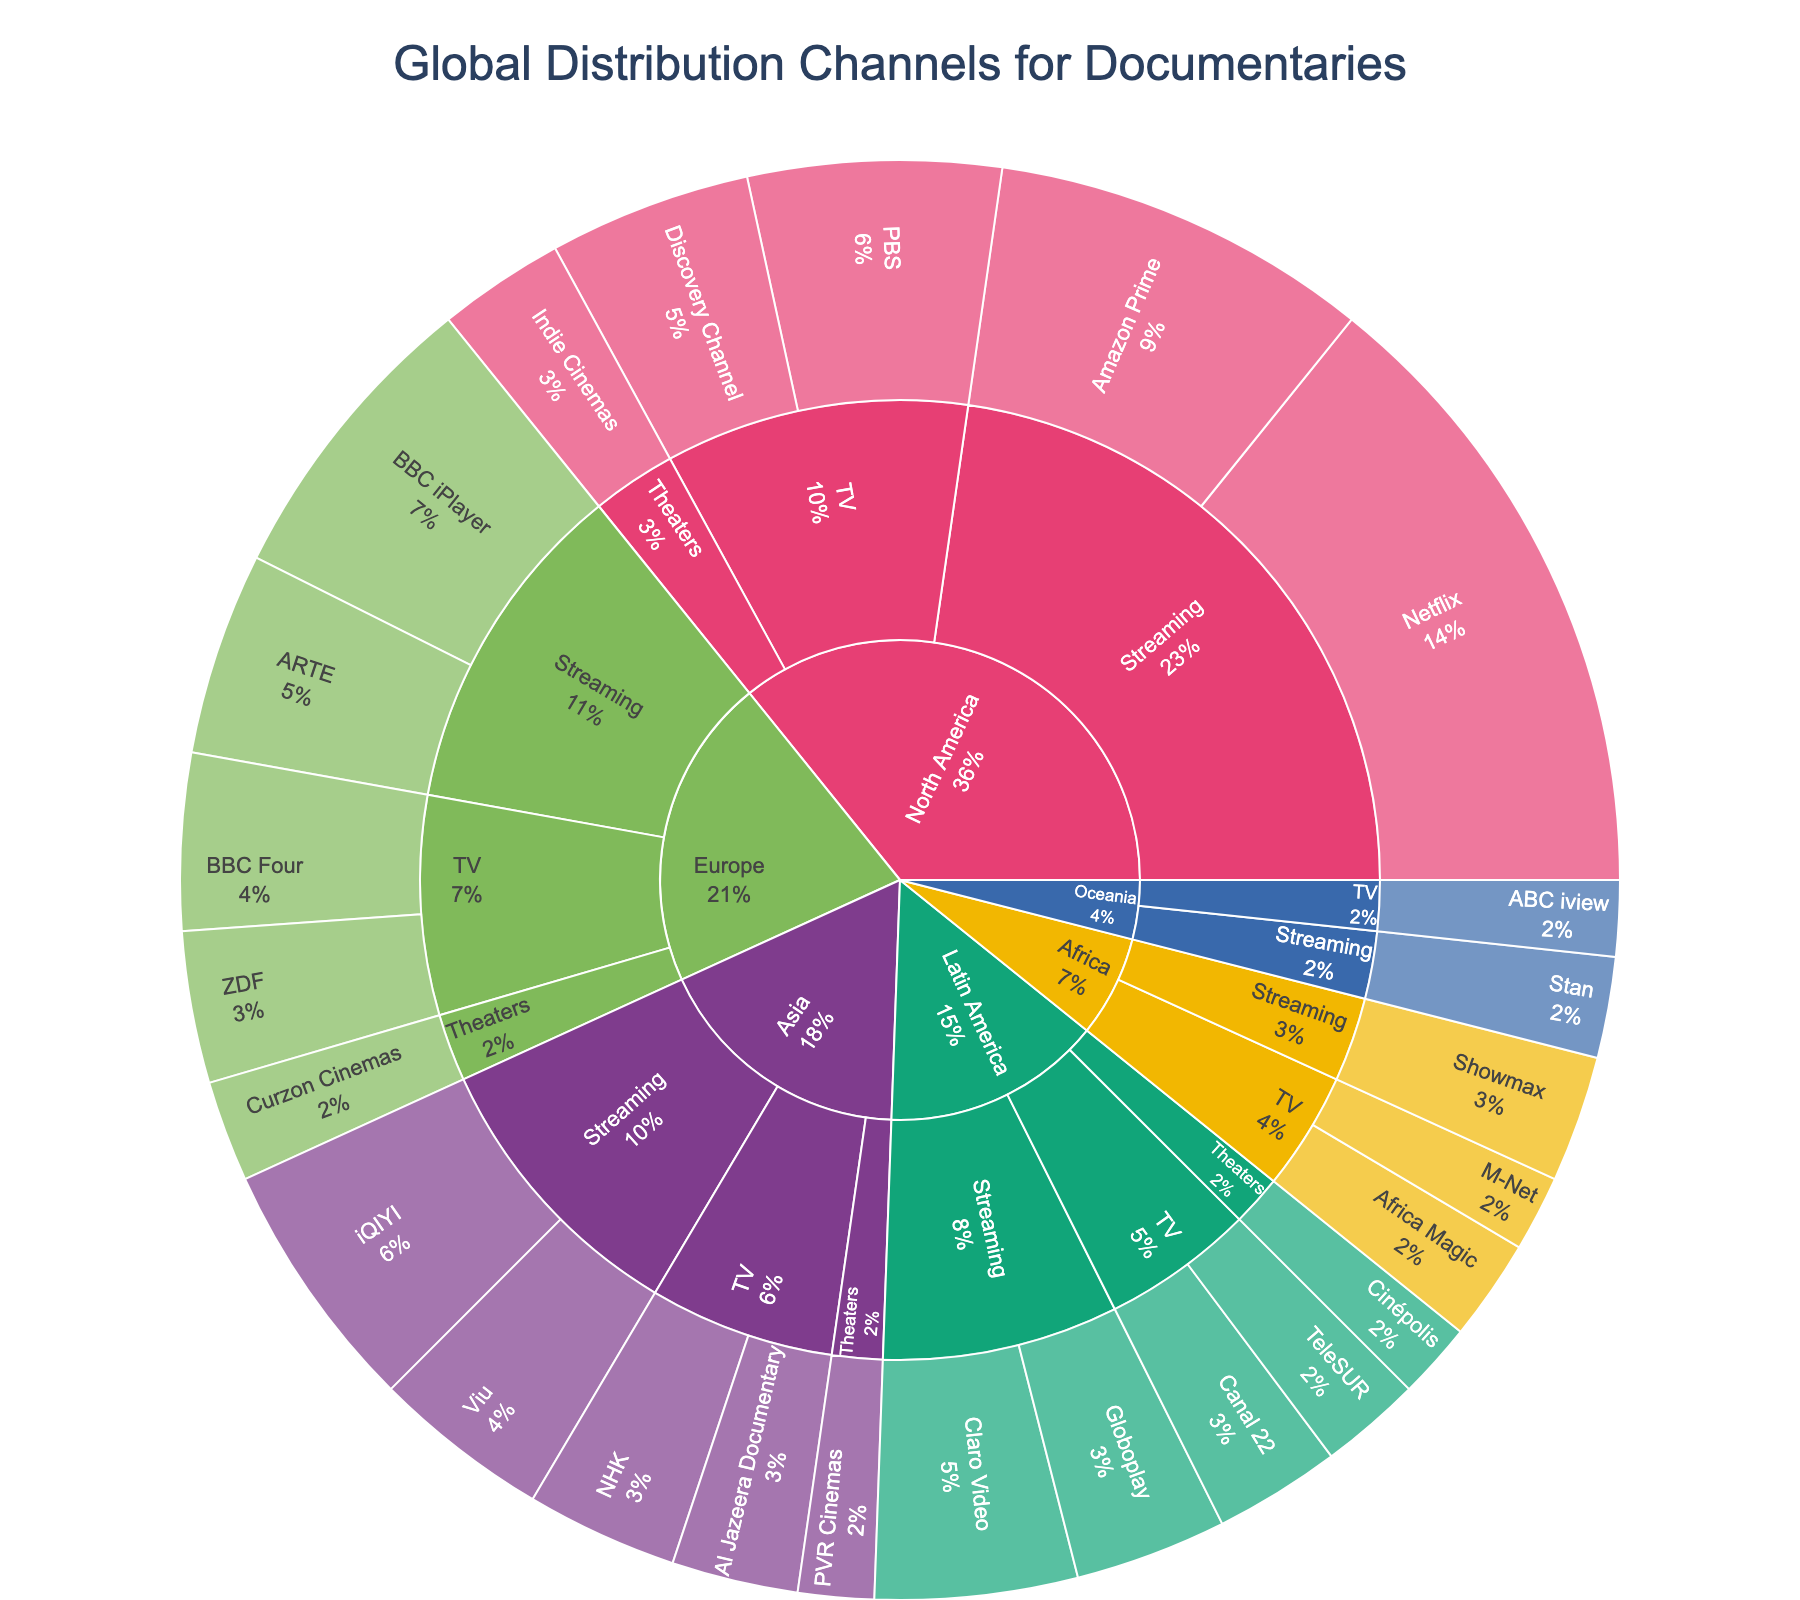What is the title of the figure? The title is prominently displayed at the top of the figure. It provides insight into the main focus of the plot.
Answer: Global Distribution Channels for Documentaries Which region has the most diverse set of distribution channels? By looking at the sunburst plot, we can observe which region has the most subdivisions branching out into different mediums and channels. North America has the most diverse set of distribution channels, with multiple branches under Streaming, TV, and Theaters.
Answer: North America What percentage of global distribution does Netflix account for? In the sunburst plot, we locate Netflix under North America -> Streaming and note the percentage value listed. Netflix accounts for 25%.
Answer: 25% Between Europe and Asia, which region has a higher percentage of Streaming distribution? We can look at the sections for Europe and Asia, then identify the percentages for the Streaming category under each. Europe has a combined streaming percentage of 12% (BBC iPlayer) + 8% (ARTE) = 20%. Asia has 10% (iQIYI) + 7% (Viu) = 17%. Thus, Europe has a higher percentage of Streaming distribution.
Answer: Europe What is the total percentage of TV distribution channels in Latin America? Identify the TV channels under Latin America and sum their percentages: Canal 22 is 5% and TeleSUR is 4%. Therefore, the total is 5% + 4% = 9%.
Answer: 9% Which channel has the highest percentage in Africa, and what is the percentage? By examining the branches under Africa, we identify the channel with the highest percentage. Showmax (Streaming) has the highest percentage in Africa with 5%.
Answer: Showmax, 5% How does the percentage of TV distribution in North America compare to Europe? Calculate the sum of percentages for TV channels in North America (PBS: 10%, Discovery Channel: 8%) and Europe (BBC Four: 7%, ZDF: 6%). North America has a total TV distribution of 18%, and Europe has 13%. Therefore, TV distribution in North America is higher.
Answer: North America has a higher TV distribution (18% vs 13%) What is the most popular medium for documentaries globally? By analyzing all sections for each region and aggregating the percentages per medium, Streaming appears most frequently and has the highest combined percentages.
Answer: Streaming What percentage of global distribution is represented by Theaters in Asia? Locate the Theaters section under Asia and sum the percentages. PVR Cinemas accounts for 3% in Theaters in Asia.
Answer: 3% Among Africa, Latin America, and Oceania, which region has the highest streaming distribution? Compare the streaming distribution percentages for each region: Africa (Showmax 5%), Latin America (Claro Video 8%, Globoplay 6%), and Oceania (Stan 4%). Latin America has a total of 14%, which is the highest.
Answer: Latin America 